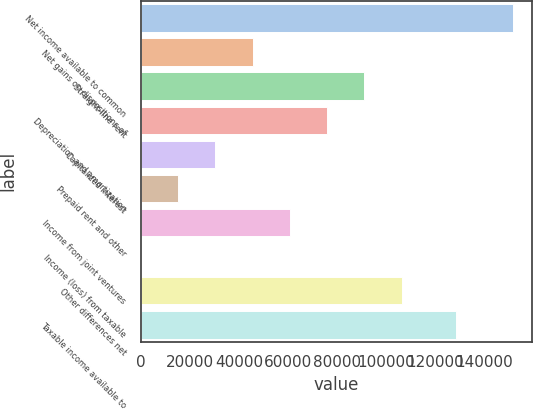Convert chart to OTSL. <chart><loc_0><loc_0><loc_500><loc_500><bar_chart><fcel>Net income available to common<fcel>Net gains on dispositions of<fcel>Straight-line rent<fcel>Depreciation and amortization<fcel>Capitalized interest<fcel>Prepaid rent and other<fcel>Income from joint ventures<fcel>Income (loss) from taxable<fcel>Other differences net<fcel>Taxable income available to<nl><fcel>151927<fcel>45604.7<fcel>91171.4<fcel>75982.5<fcel>30415.8<fcel>15226.9<fcel>60793.6<fcel>38<fcel>106360<fcel>128331<nl></chart> 